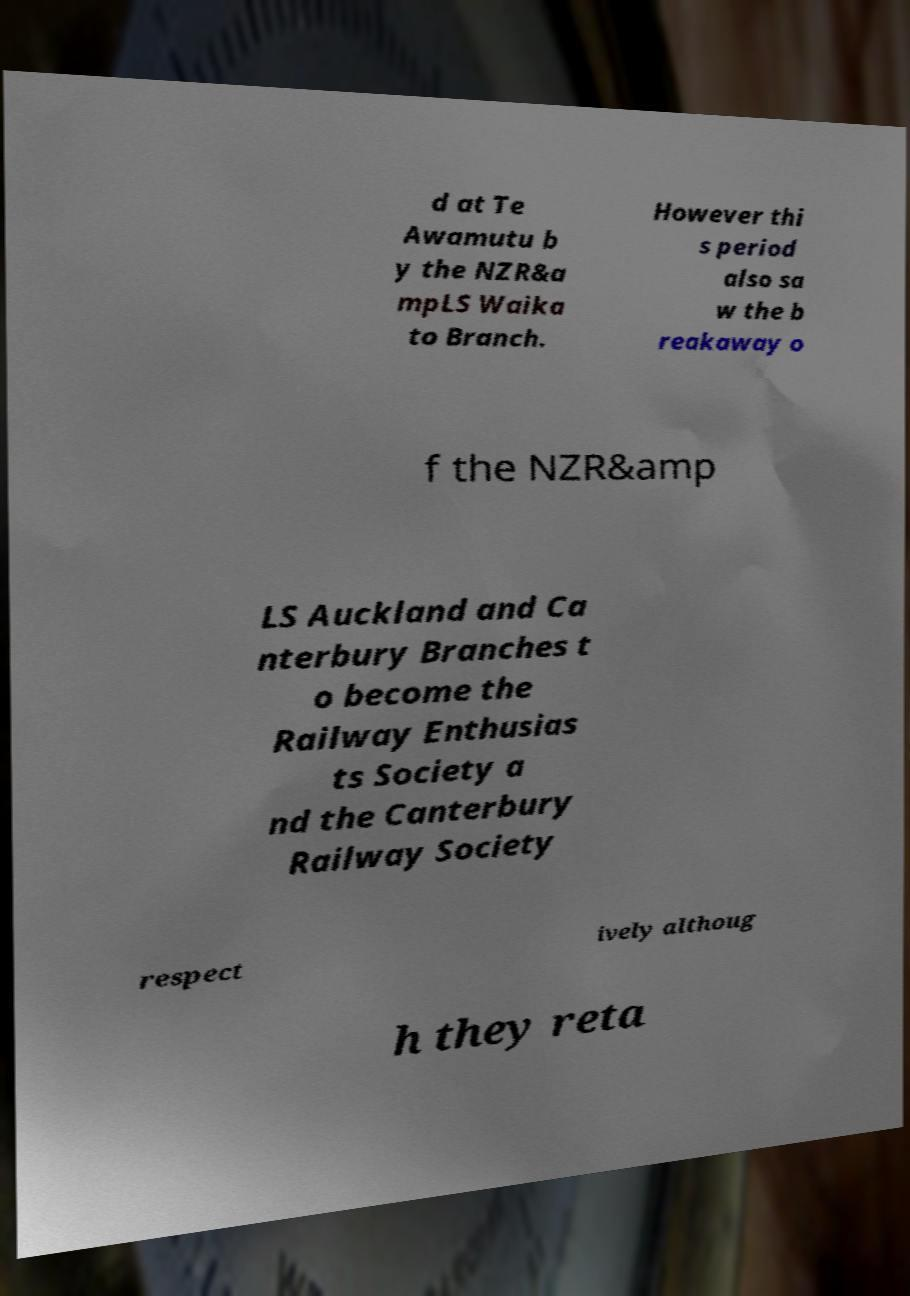Please identify and transcribe the text found in this image. d at Te Awamutu b y the NZR&a mpLS Waika to Branch. However thi s period also sa w the b reakaway o f the NZR&amp LS Auckland and Ca nterbury Branches t o become the Railway Enthusias ts Society a nd the Canterbury Railway Society respect ively althoug h they reta 